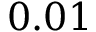Convert formula to latex. <formula><loc_0><loc_0><loc_500><loc_500>0 . 0 1</formula> 